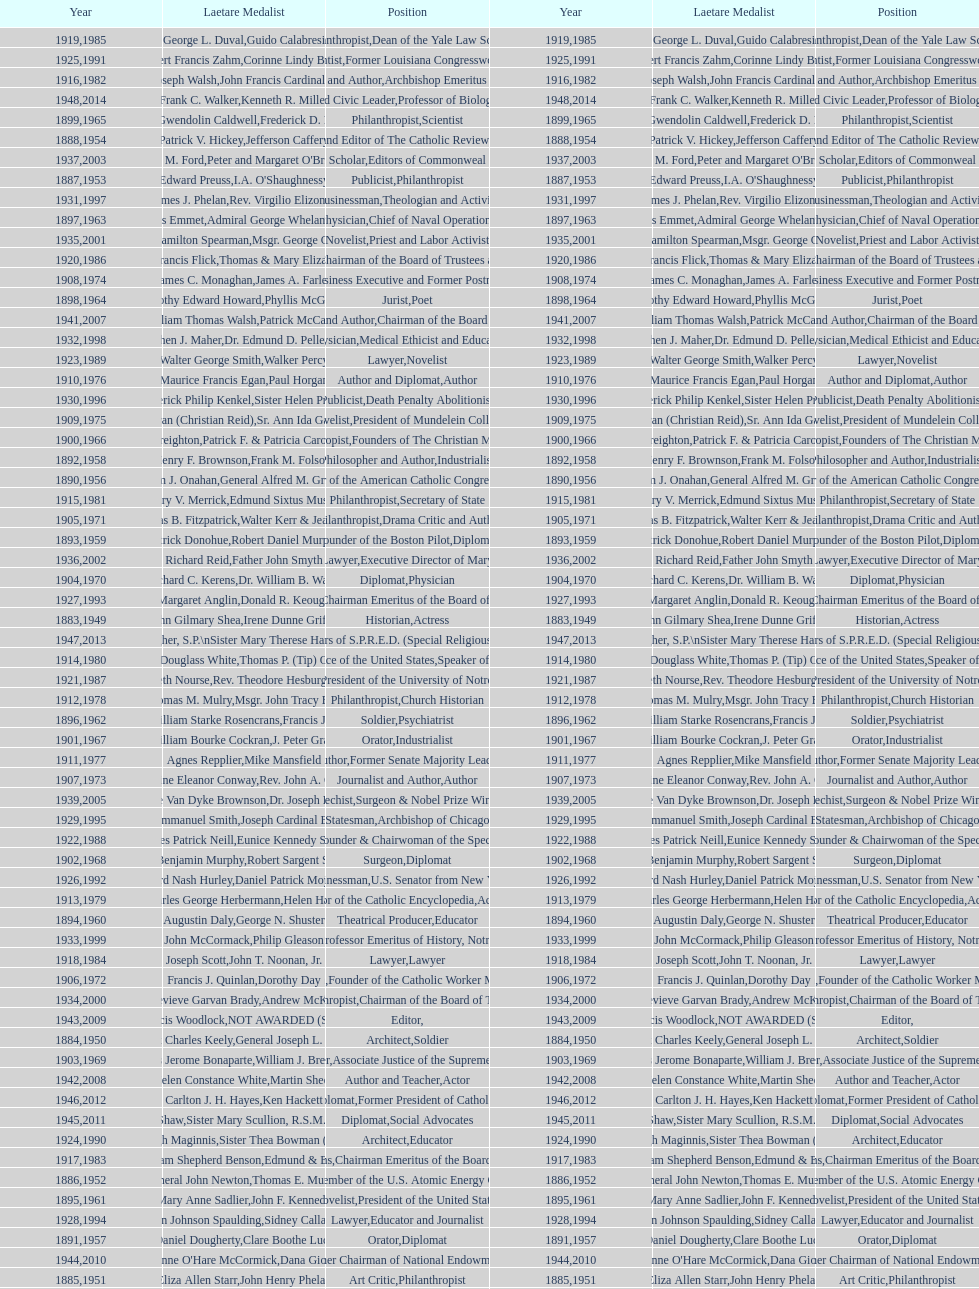Who won the medal after thomas e. murray in 1952? I.A. O'Shaughnessy. 